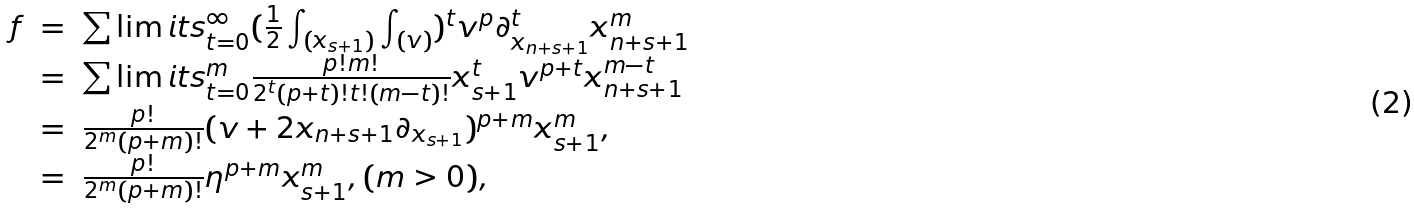Convert formula to latex. <formula><loc_0><loc_0><loc_500><loc_500>\begin{array} { l l l } f & = & \sum \lim i t s _ { t = 0 } ^ { \infty } ( \frac { 1 } { 2 } \int _ { ( x _ { s + 1 } ) } \int _ { ( v ) } ) ^ { t } v ^ { p } \partial _ { x _ { n + s + 1 } } ^ { t } x _ { n + s + 1 } ^ { m } \\ & = & \sum \lim i t s _ { t = 0 } ^ { m } \frac { p ! m ! } { 2 ^ { t } ( p + t ) ! t ! ( m - t ) ! } x _ { s + 1 } ^ { t } v ^ { p + t } x _ { n + s + 1 } ^ { m - t } \\ & = & \frac { p ! } { 2 ^ { m } ( p + m ) ! } ( v + 2 x _ { n + s + 1 } \partial _ { x _ { s + 1 } } ) ^ { p + m } x _ { s + 1 } ^ { m } , \\ & = & \frac { p ! } { 2 ^ { m } ( p + m ) ! } \eta ^ { p + m } x _ { s + 1 } ^ { m } , ( m > 0 ) , \end{array}</formula> 